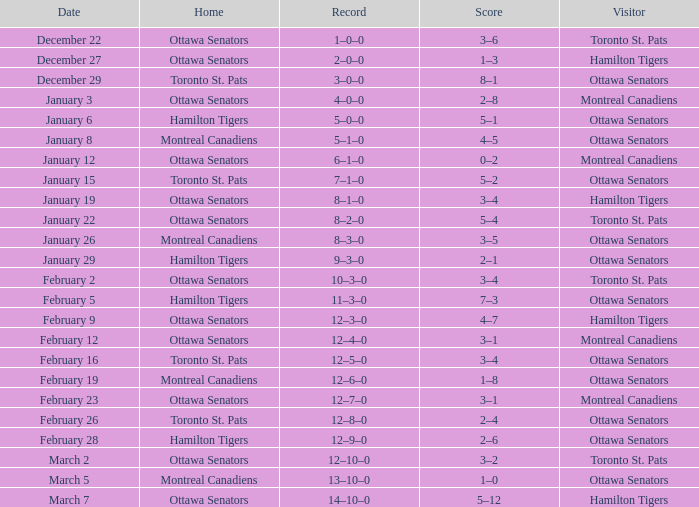Who was the home team when the vistor team was the Montreal Canadiens on February 12? Ottawa Senators. 